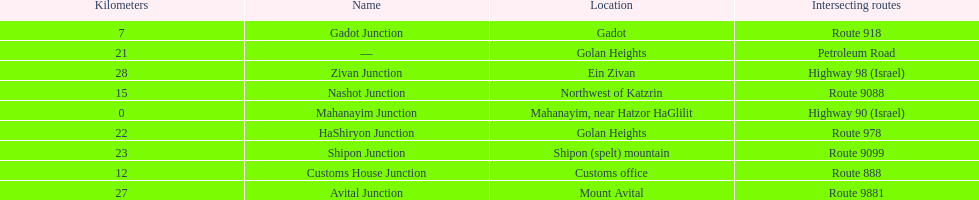Could you parse the entire table as a dict? {'header': ['Kilometers', 'Name', 'Location', 'Intersecting routes'], 'rows': [['7', 'Gadot Junction', 'Gadot', 'Route 918'], ['21', '—', 'Golan Heights', 'Petroleum Road'], ['28', 'Zivan Junction', 'Ein Zivan', 'Highway 98 (Israel)'], ['15', 'Nashot Junction', 'Northwest of Katzrin', 'Route 9088'], ['0', 'Mahanayim Junction', 'Mahanayim, near Hatzor HaGlilit', 'Highway 90 (Israel)'], ['22', 'HaShiryon Junction', 'Golan Heights', 'Route 978'], ['23', 'Shipon Junction', 'Shipon (spelt) mountain', 'Route 9099'], ['12', 'Customs House Junction', 'Customs office', 'Route 888'], ['27', 'Avital Junction', 'Mount Avital', 'Route 9881']]} What junction is the furthest from mahanayim junction? Zivan Junction. 